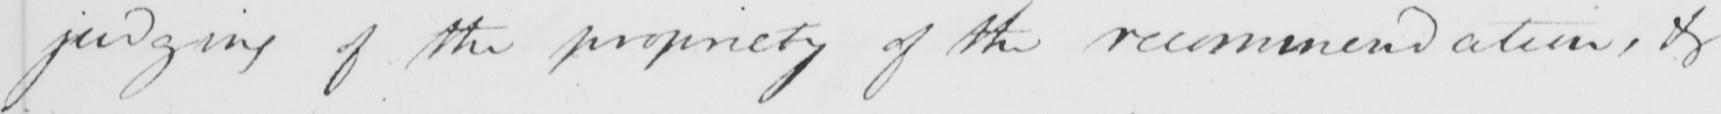Please transcribe the handwritten text in this image. judging of the propriety of the recommendation , or 